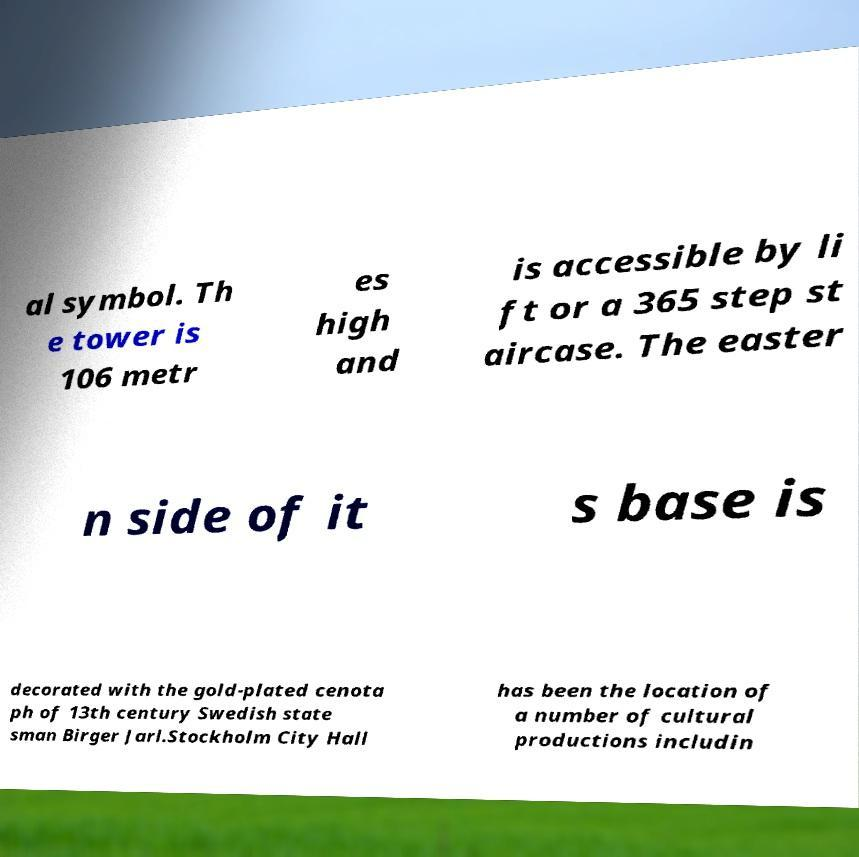Can you read and provide the text displayed in the image?This photo seems to have some interesting text. Can you extract and type it out for me? al symbol. Th e tower is 106 metr es high and is accessible by li ft or a 365 step st aircase. The easter n side of it s base is decorated with the gold-plated cenota ph of 13th century Swedish state sman Birger Jarl.Stockholm City Hall has been the location of a number of cultural productions includin 